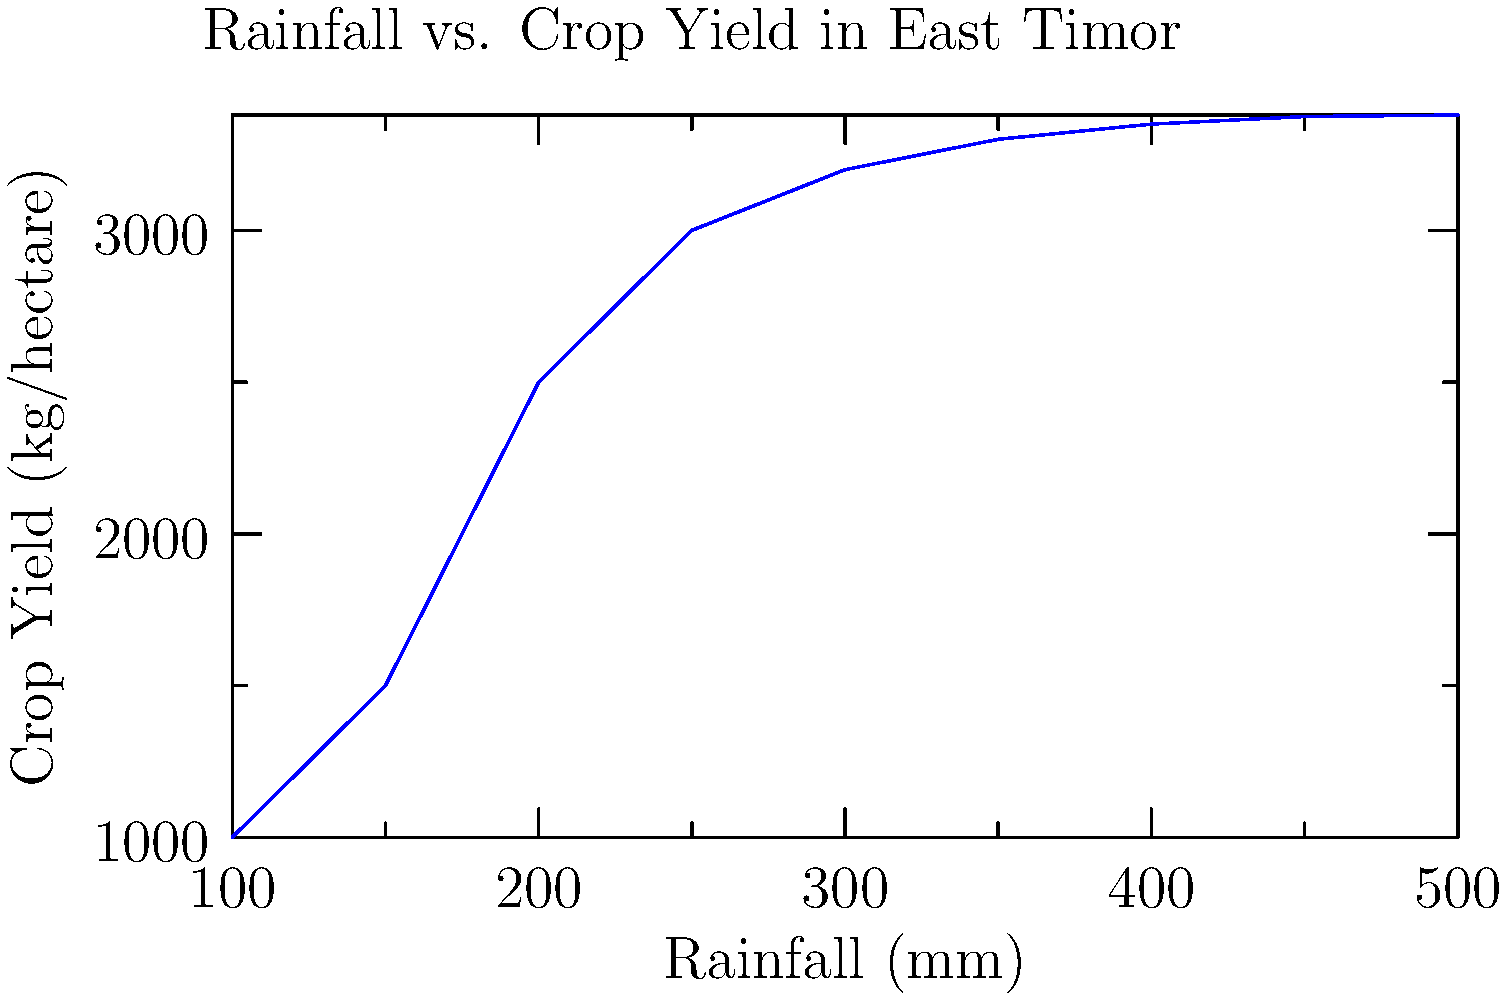Based on the graph showing the relationship between rainfall and crop yield in East Timor, what is the approximate maximum crop yield that can be achieved, and at what rainfall level does the yield start to plateau? To answer this question, we need to analyze the graph carefully:

1. Observe the overall trend: As rainfall increases, crop yield generally increases.

2. Identify the maximum yield:
   - The curve reaches its highest point at approximately 3380 kg/hectare.

3. Determine where the yield plateaus:
   - Look for where the curve starts to level off.
   - This occurs around 350-400 mm of rainfall.

4. Analyze the yield increase:
   - Below 350 mm, the yield increases rapidly with rainfall.
   - After 400 mm, the yield increase is minimal.

5. Conclude:
   - The maximum yield is about 3380 kg/hectare.
   - The yield starts to plateau at around 350-400 mm of rainfall.

This information is crucial for agricultural development in East Timor, as it helps determine optimal irrigation strategies and crop selection based on typical rainfall patterns in different regions.
Answer: Maximum yield: ~3380 kg/hectare; Plateau starts: 350-400 mm rainfall 